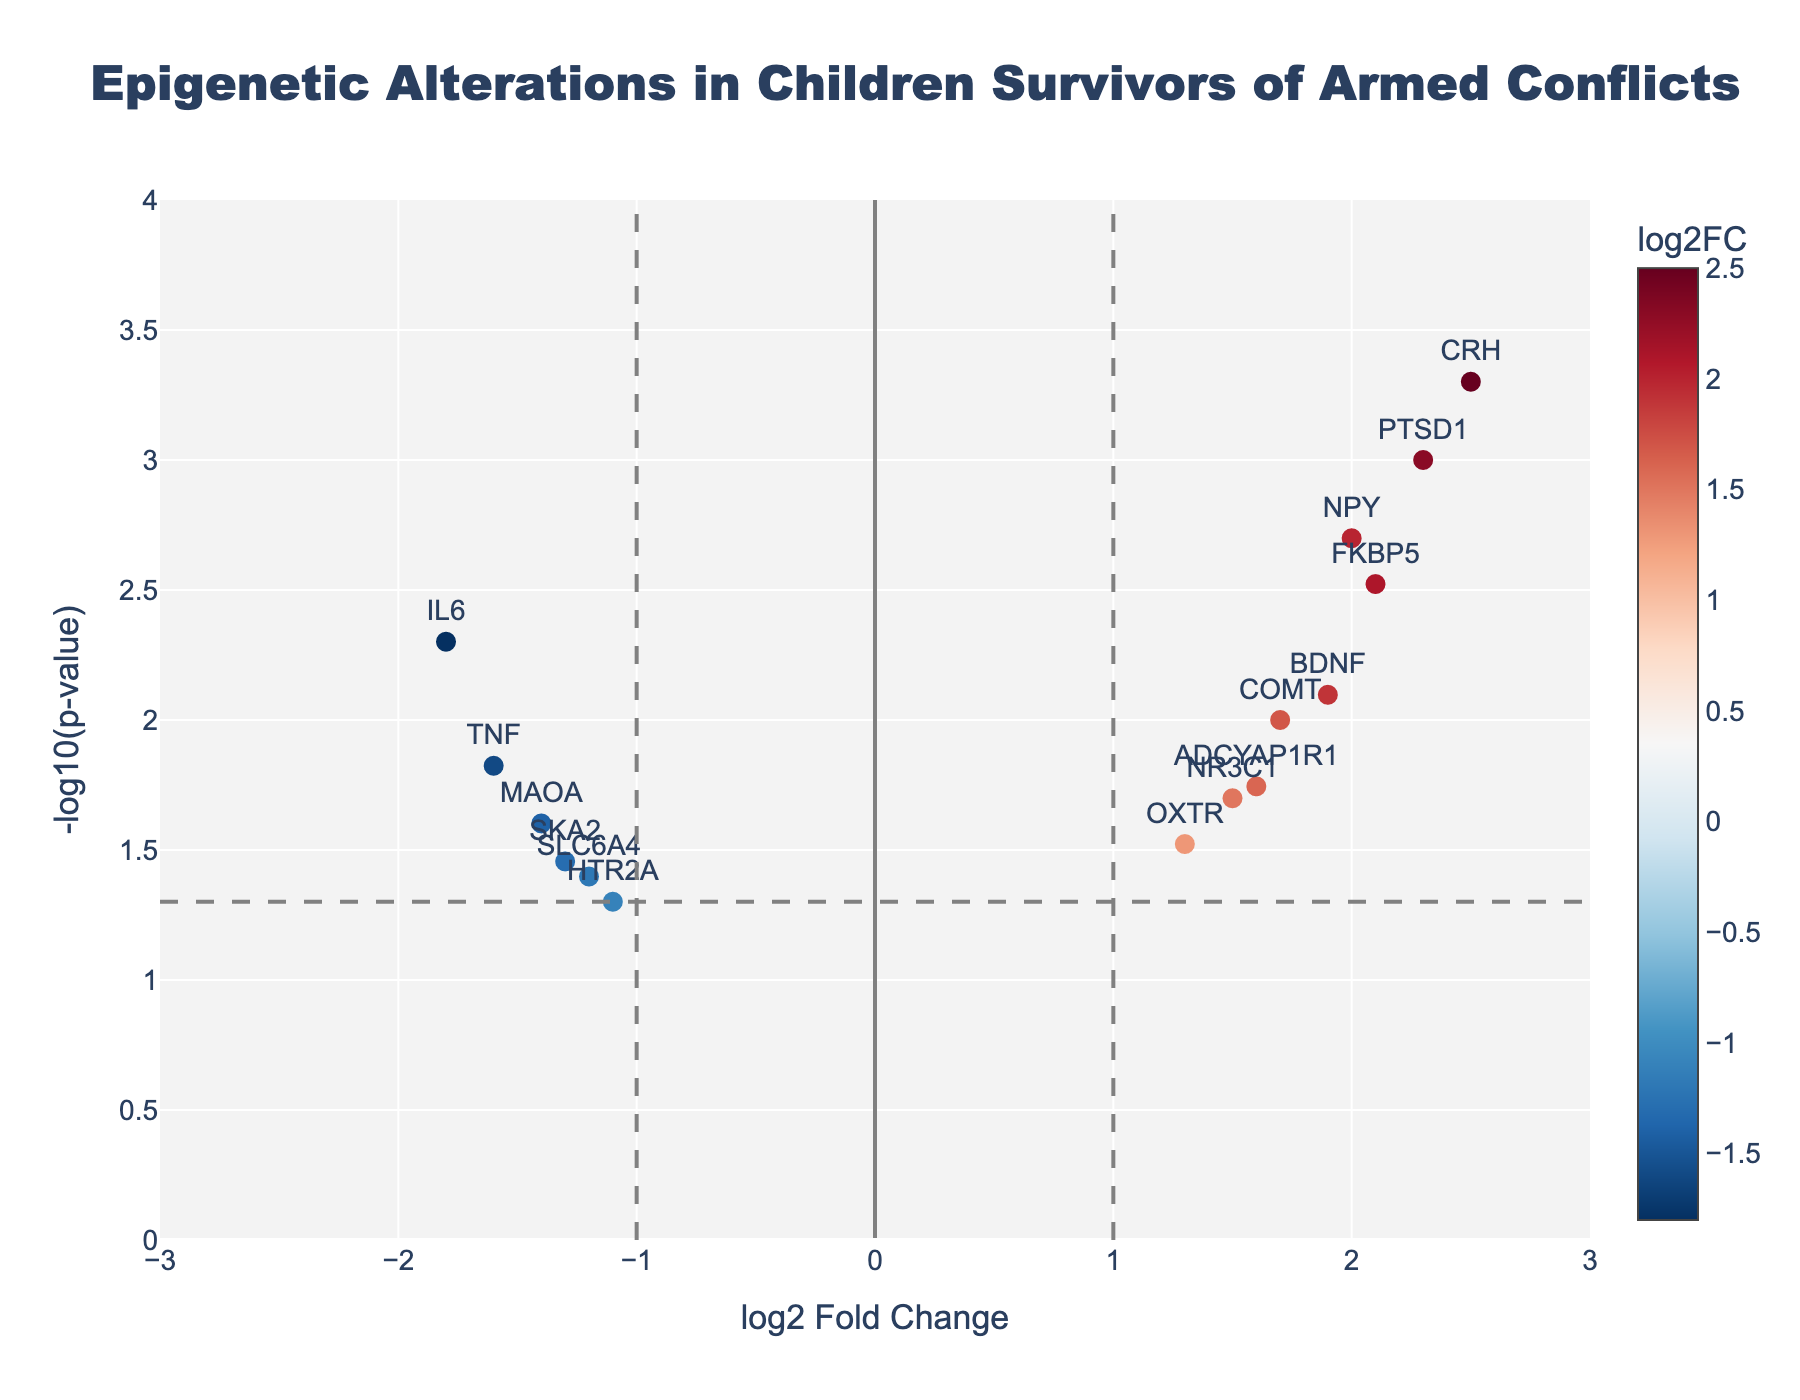What is the title of the figure? The title of the figure is typically located at the top and often describes the main topic or data being displayed. In this case, the title is "Epigenetic Alterations in Children Survivors of Armed Conflicts."
Answer: Epigenetic Alterations in Children Survivors of Armed Conflicts How many genes are shown in the plot? To determine the number of genes, one needs to count each marker on the plot, which corresponds to a gene. Looking at the data, there are 15 genes listed.
Answer: 15 Which gene has the highest -log10(p-value)? The highest -log10(p-value) corresponds to the point with the greatest vertical distance from the x-axis. Here, it is "CRH" with the lowest p-value of 0.0005. The -log10(0.0005) is approximately 3.3, making it the highest.
Answer: CRH Which gene has the highest positive log2FoldChange? Among the genes with positive log2FoldChange, "CRH" has the highest with a value of 2.5. This can be seen as the farthest point to the right on the x-axis in the positive direction.
Answer: CRH Which gene has the largest absolute log2FoldChange value? The absolute log2FoldChange value measures the magnitude regardless of direction (positive or negative). The "CRH" gene has the highest positive log2FoldChange of 2.5, making it the largest.
Answer: CRH How many genes exceed the significance threshold of p-value < 0.05? The significance threshold is marked with a horizontal line at -log10(0.05) ≈ 1.3. Counting the number of points above this line gives the number of significant genes. There are 10 such genes.
Answer: 10 Which genes have a log2FoldChange between -1 and 1, and are they significant? To find out, we look for genes located between the vertical lines at -1 and 1. According to the plot, there are no genes within this range that are significant since both vertical lines and the horizontal threshold line indicate the boundaries.
Answer: None Which two genes show the most similar p-values? To find the most similar p-values, look for genes with close vertical positions which means similar -log10(p-value) values. Here, "ADCYAP1R1" (0.018) and "NR3C1" (0.02) are closely matched.
Answer: ADCYAP1R1 and NR3C1 What is the log2FoldChange for the gene "BDNF," and is it statistically significant? For the gene "BDNF," its log2FoldChange is 1.9. Checking against the significance threshold, we see "BDNF" lies above the line at -log10(0.05), meaning it is statistically significant.
Answer: 1.9; Yes 